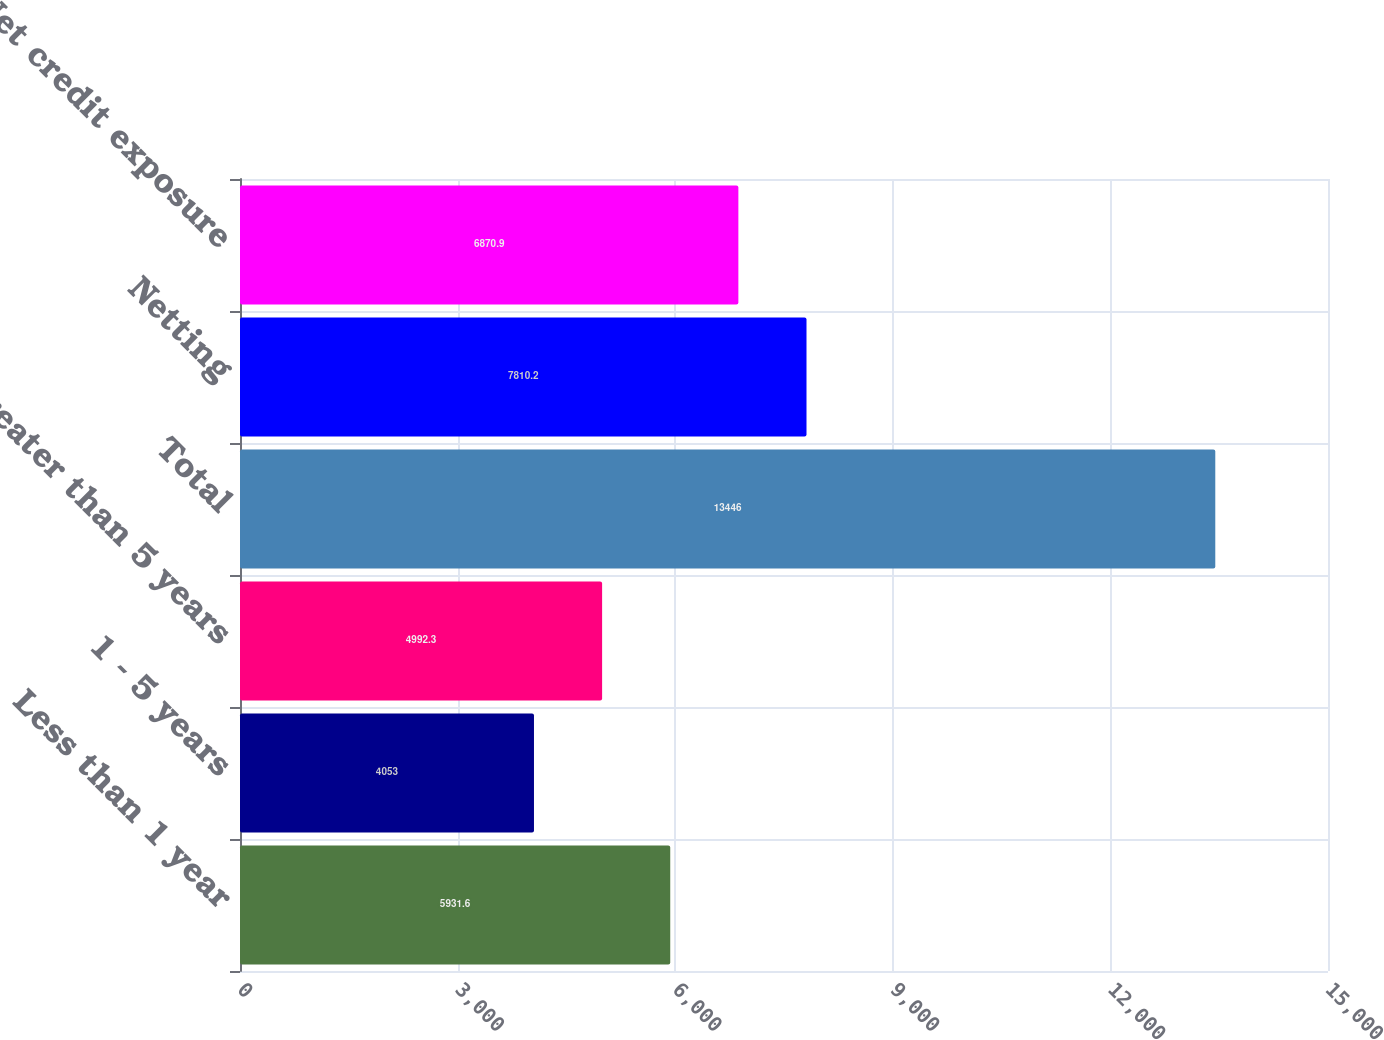Convert chart. <chart><loc_0><loc_0><loc_500><loc_500><bar_chart><fcel>Less than 1 year<fcel>1 - 5 years<fcel>Greater than 5 years<fcel>Total<fcel>Netting<fcel>Net credit exposure<nl><fcel>5931.6<fcel>4053<fcel>4992.3<fcel>13446<fcel>7810.2<fcel>6870.9<nl></chart> 